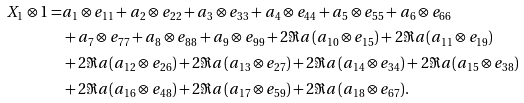<formula> <loc_0><loc_0><loc_500><loc_500>X _ { 1 } \otimes 1 = & a _ { 1 } \otimes e _ { 1 1 } + a _ { 2 } \otimes e _ { 2 2 } + a _ { 3 } \otimes e _ { 3 3 } + a _ { 4 } \otimes e _ { 4 4 } + a _ { 5 } \otimes e _ { 5 5 } + a _ { 6 } \otimes e _ { 6 6 } \\ & + a _ { 7 } \otimes e _ { 7 7 } + a _ { 8 } \otimes e _ { 8 8 } + a _ { 9 } \otimes e _ { 9 9 } + 2 \Re a ( a _ { 1 0 } \otimes e _ { 1 5 } ) + 2 \Re a ( a _ { 1 1 } \otimes e _ { 1 9 } ) \\ & + 2 \Re a ( a _ { 1 2 } \otimes e _ { 2 6 } ) + 2 \Re a ( a _ { 1 3 } \otimes e _ { 2 7 } ) + 2 \Re a ( a _ { 1 4 } \otimes e _ { 3 4 } ) + 2 \Re a ( a _ { 1 5 } \otimes e _ { 3 8 } ) \\ & + 2 \Re a ( a _ { 1 6 } \otimes e _ { 4 8 } ) + 2 \Re a ( a _ { 1 7 } \otimes e _ { 5 9 } ) + 2 \Re a ( a _ { 1 8 } \otimes e _ { 6 7 } ) .</formula> 